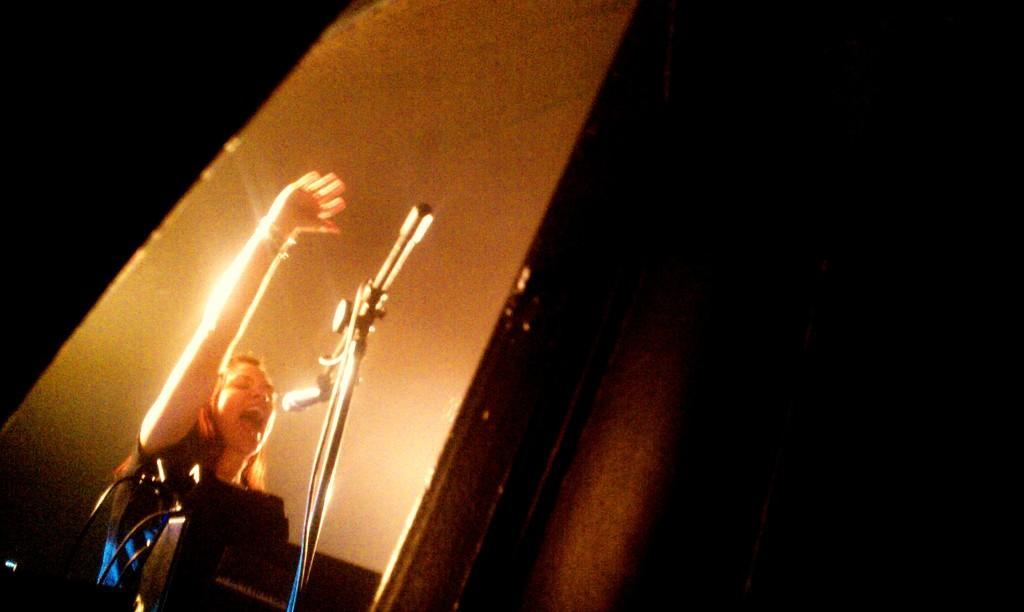How would you summarize this image in a sentence or two? In this image we can see a person who is playing the musical instrument in front of the mic. 